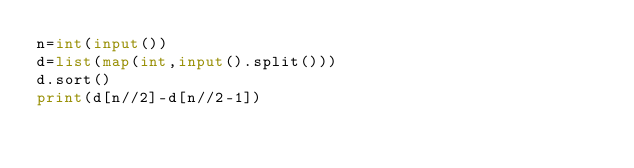<code> <loc_0><loc_0><loc_500><loc_500><_Python_>n=int(input())
d=list(map(int,input().split()))
d.sort()
print(d[n//2]-d[n//2-1])</code> 